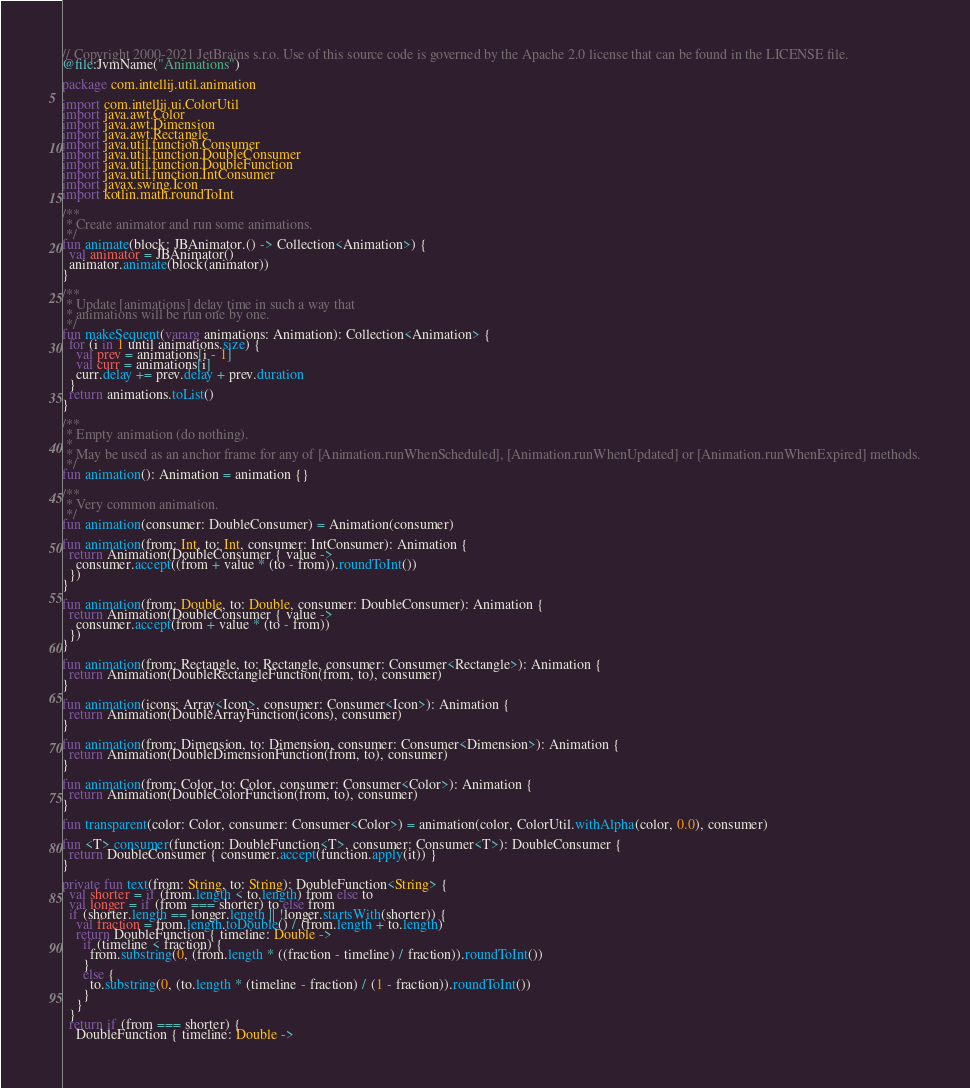<code> <loc_0><loc_0><loc_500><loc_500><_Kotlin_>// Copyright 2000-2021 JetBrains s.r.o. Use of this source code is governed by the Apache 2.0 license that can be found in the LICENSE file.
@file:JvmName("Animations")

package com.intellij.util.animation

import com.intellij.ui.ColorUtil
import java.awt.Color
import java.awt.Dimension
import java.awt.Rectangle
import java.util.function.Consumer
import java.util.function.DoubleConsumer
import java.util.function.DoubleFunction
import java.util.function.IntConsumer
import javax.swing.Icon
import kotlin.math.roundToInt

/**
 * Create animator and run some animations.
 */
fun animate(block: JBAnimator.() -> Collection<Animation>) {
  val animator = JBAnimator()
  animator.animate(block(animator))
}

/**
 * Update [animations] delay time in such a way that
 * animations will be run one by one.
 */
fun makeSequent(vararg animations: Animation): Collection<Animation> {
  for (i in 1 until animations.size) {
    val prev = animations[i - 1]
    val curr = animations[i]
    curr.delay += prev.delay + prev.duration
  }
  return animations.toList()
}

/**
 * Empty animation (do nothing).
 *
 * May be used as an anchor frame for any of [Animation.runWhenScheduled], [Animation.runWhenUpdated] or [Animation.runWhenExpired] methods.
 */
fun animation(): Animation = animation {}

/**
 * Very common animation.
 */
fun animation(consumer: DoubleConsumer) = Animation(consumer)

fun animation(from: Int, to: Int, consumer: IntConsumer): Animation {
  return Animation(DoubleConsumer { value ->
    consumer.accept((from + value * (to - from)).roundToInt())
  })
}

fun animation(from: Double, to: Double, consumer: DoubleConsumer): Animation {
  return Animation(DoubleConsumer { value ->
    consumer.accept(from + value * (to - from))
  })
}

fun animation(from: Rectangle, to: Rectangle, consumer: Consumer<Rectangle>): Animation {
  return Animation(DoubleRectangleFunction(from, to), consumer)
}

fun animation(icons: Array<Icon>, consumer: Consumer<Icon>): Animation {
  return Animation(DoubleArrayFunction(icons), consumer)
}

fun animation(from: Dimension, to: Dimension, consumer: Consumer<Dimension>): Animation {
  return Animation(DoubleDimensionFunction(from, to), consumer)
}

fun animation(from: Color, to: Color, consumer: Consumer<Color>): Animation {
  return Animation(DoubleColorFunction(from, to), consumer)
}

fun transparent(color: Color, consumer: Consumer<Color>) = animation(color, ColorUtil.withAlpha(color, 0.0), consumer)

fun <T> consumer(function: DoubleFunction<T>, consumer: Consumer<T>): DoubleConsumer {
  return DoubleConsumer { consumer.accept(function.apply(it)) }
}

private fun text(from: String, to: String): DoubleFunction<String> {
  val shorter = if (from.length < to.length) from else to
  val longer = if (from === shorter) to else from
  if (shorter.length == longer.length || !longer.startsWith(shorter)) {
    val fraction = from.length.toDouble() / (from.length + to.length)
    return DoubleFunction { timeline: Double ->
      if (timeline < fraction) {
        from.substring(0, (from.length * ((fraction - timeline) / fraction)).roundToInt())
      }
      else {
        to.substring(0, (to.length * (timeline - fraction) / (1 - fraction)).roundToInt())
      }
    }
  }
  return if (from === shorter) {
    DoubleFunction { timeline: Double -></code> 